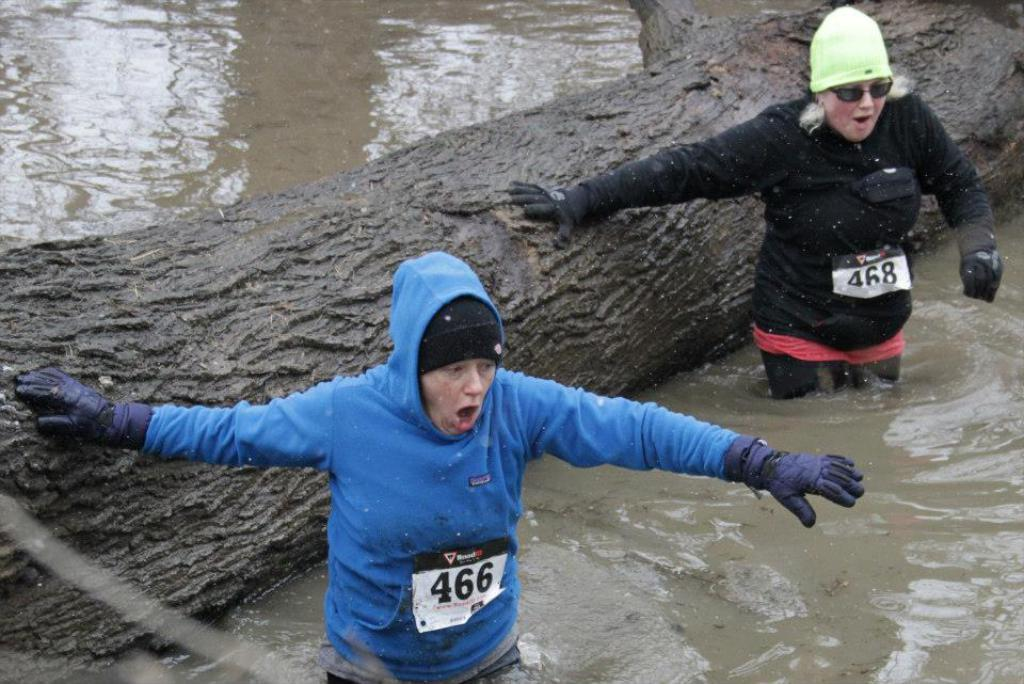What natural element can be seen in the image? The bark of a tree is visible in the image. What are the two persons wearing in the image? They are wearing hand gloves in the image. What type of items are present with numbers on them? There are pages with numbers in the image. What is the liquid element visible in the image? There is water visible in the image. What type of quiver can be seen in the image? There is no quiver present in the image. Are there any farm animals visible in the image? There is no reference to farm animals in the image, so it cannot be determined if any are present. 